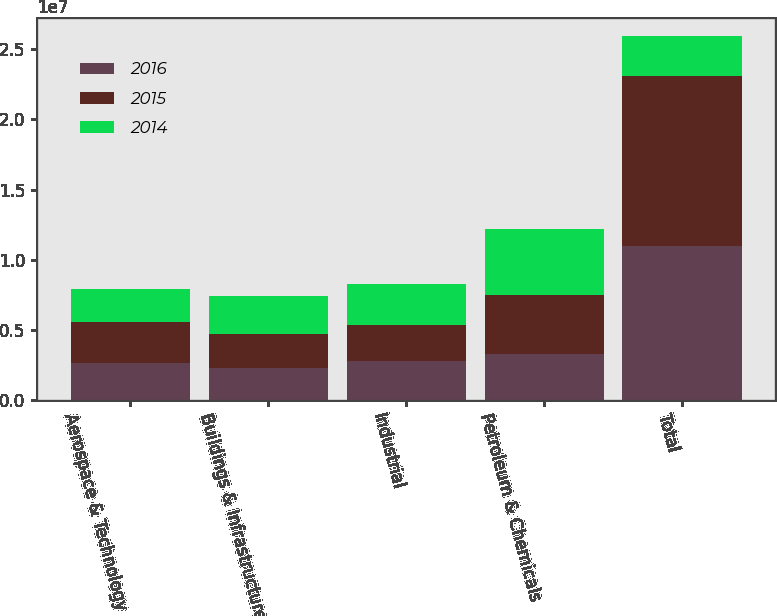Convert chart to OTSL. <chart><loc_0><loc_0><loc_500><loc_500><stacked_bar_chart><ecel><fcel>Aerospace & Technology<fcel>Buildings & Infrastructure<fcel>Industrial<fcel>Petroleum & Chemicals<fcel>Total<nl><fcel>2016<fcel>2.65743e+06<fcel>2.25351e+06<fcel>2.79371e+06<fcel>3.2595e+06<fcel>1.09642e+07<nl><fcel>2015<fcel>2.92475e+06<fcel>2.45838e+06<fcel>2.51757e+06<fcel>4.21413e+06<fcel>1.21148e+07<nl><fcel>2014<fcel>2.30645e+06<fcel>2.7052e+06<fcel>2.95639e+06<fcel>4.72712e+06<fcel>2.85923e+06<nl></chart> 